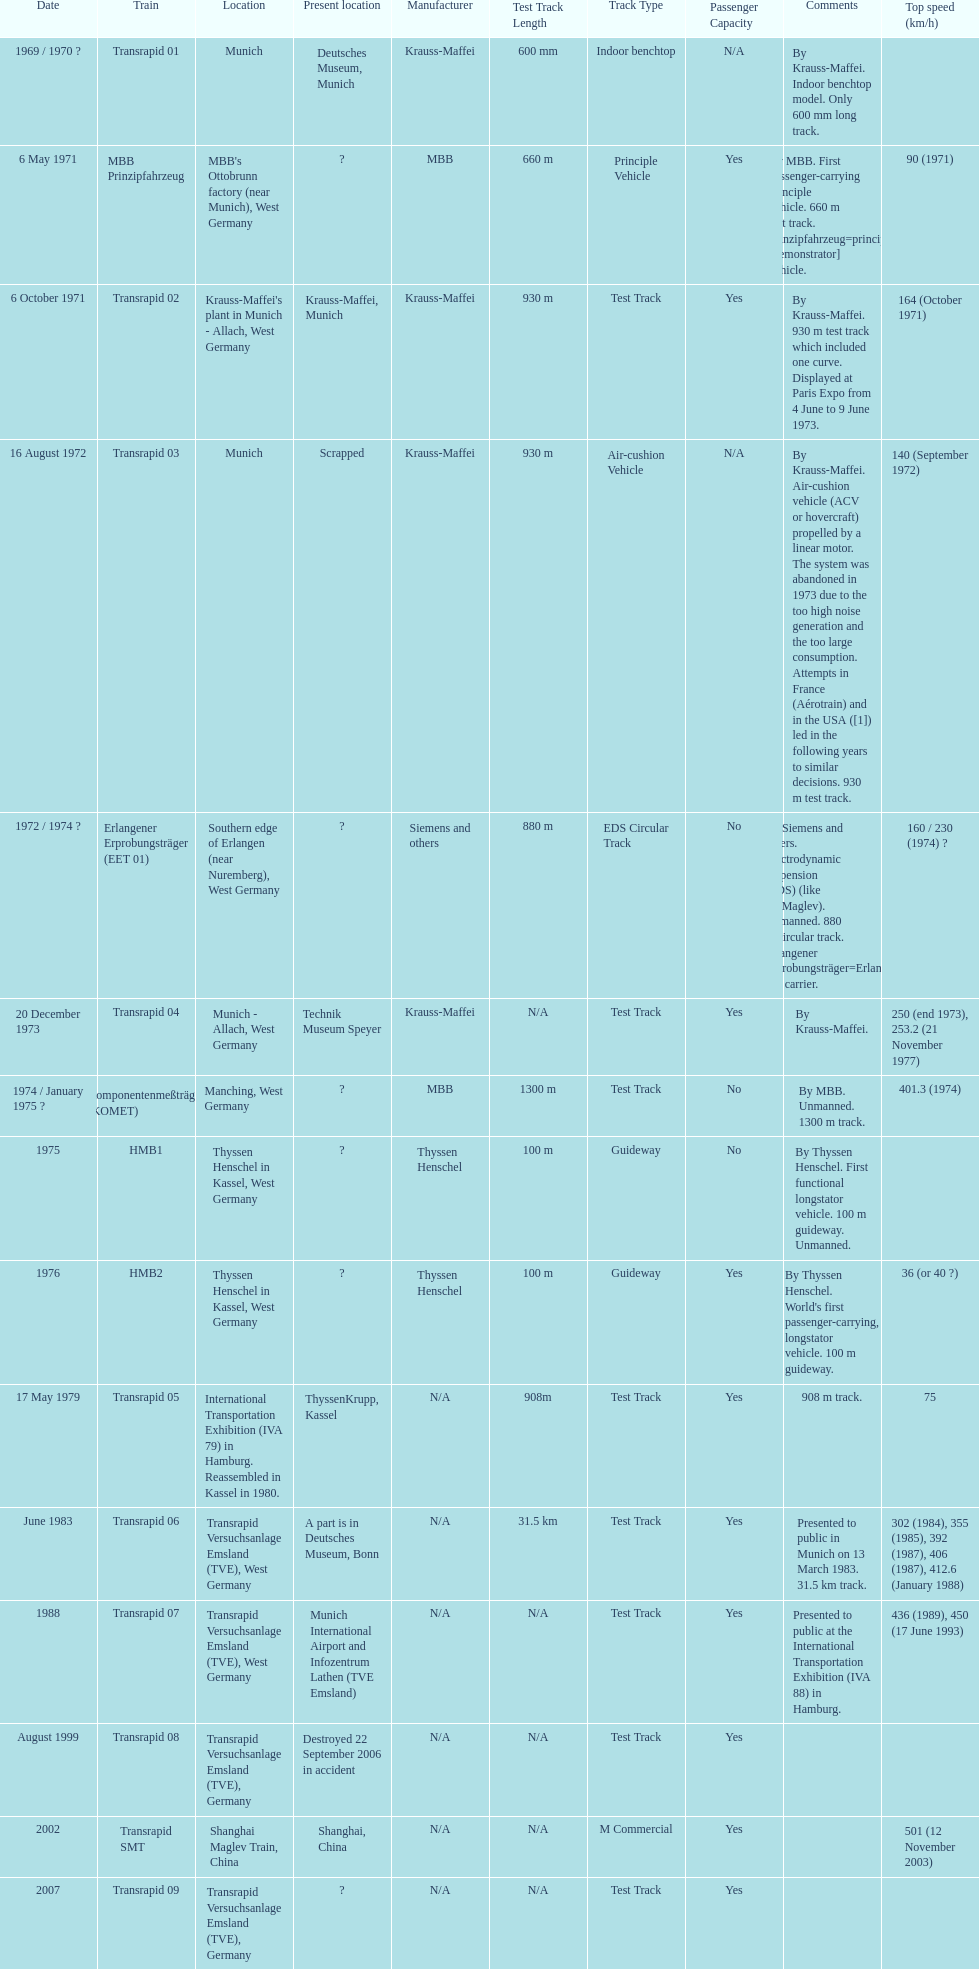High noise generation and too large consumption led to what train being scrapped? Transrapid 03. 